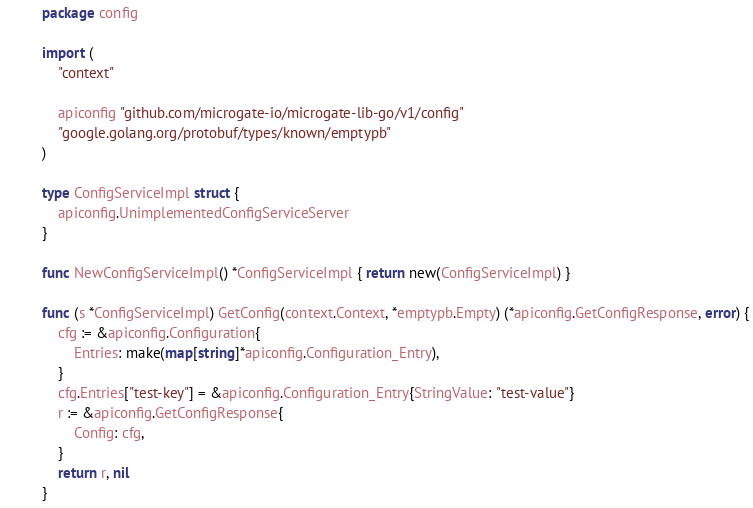<code> <loc_0><loc_0><loc_500><loc_500><_Go_>package config

import (
	"context"

	apiconfig "github.com/microgate-io/microgate-lib-go/v1/config"
	"google.golang.org/protobuf/types/known/emptypb"
)

type ConfigServiceImpl struct {
	apiconfig.UnimplementedConfigServiceServer
}

func NewConfigServiceImpl() *ConfigServiceImpl { return new(ConfigServiceImpl) }

func (s *ConfigServiceImpl) GetConfig(context.Context, *emptypb.Empty) (*apiconfig.GetConfigResponse, error) {
	cfg := &apiconfig.Configuration{
		Entries: make(map[string]*apiconfig.Configuration_Entry),
	}
	cfg.Entries["test-key"] = &apiconfig.Configuration_Entry{StringValue: "test-value"}
	r := &apiconfig.GetConfigResponse{
		Config: cfg,
	}
	return r, nil
}
</code> 